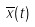<formula> <loc_0><loc_0><loc_500><loc_500>\overline { x } ( t )</formula> 